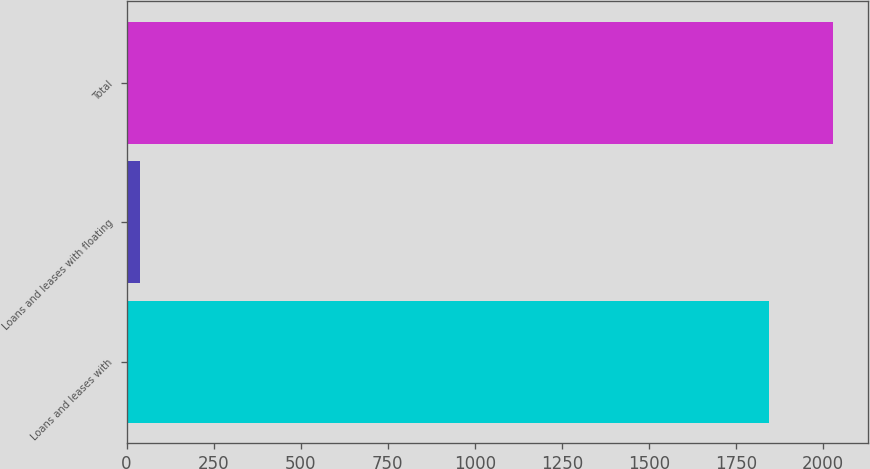Convert chart. <chart><loc_0><loc_0><loc_500><loc_500><bar_chart><fcel>Loans and leases with<fcel>Loans and leases with floating<fcel>Total<nl><fcel>1844<fcel>40<fcel>2028.4<nl></chart> 